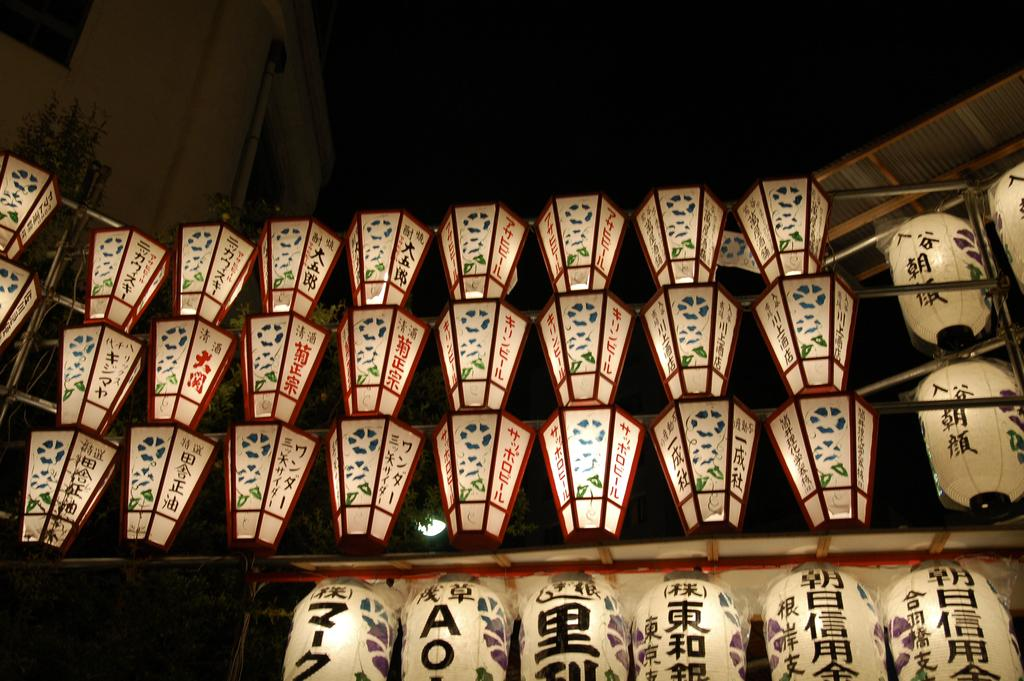What is the main feature of the image? The main feature of the image is the many lights. Can you describe the location of the lights in the image? The lights are under a roof in the image. What type of sack is being used to create the spark on the wrist in the image? There is no sack, spark, or wrist present in the image; it only features many lights under a roof. 